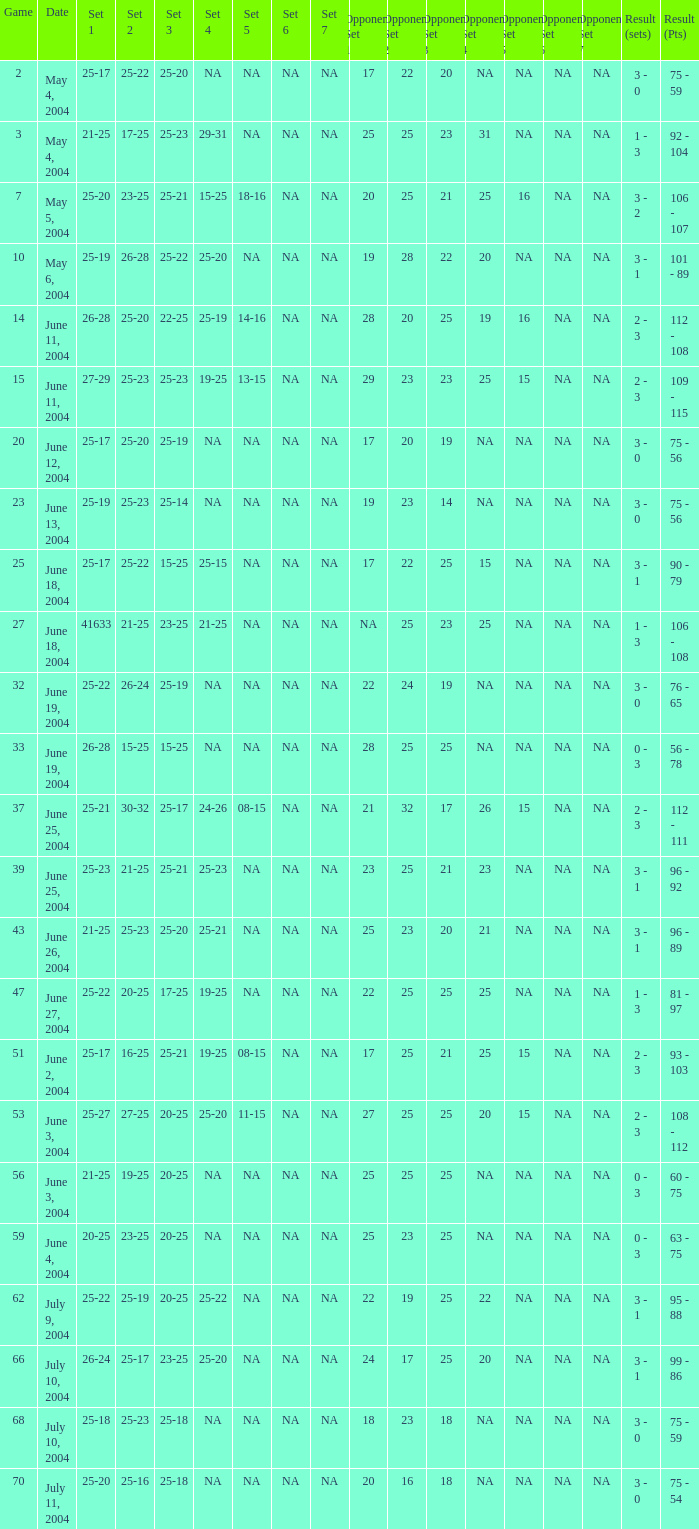What is the set 5 for the game with a set 2 of 21-25 and a set 1 of 41633? NA. 